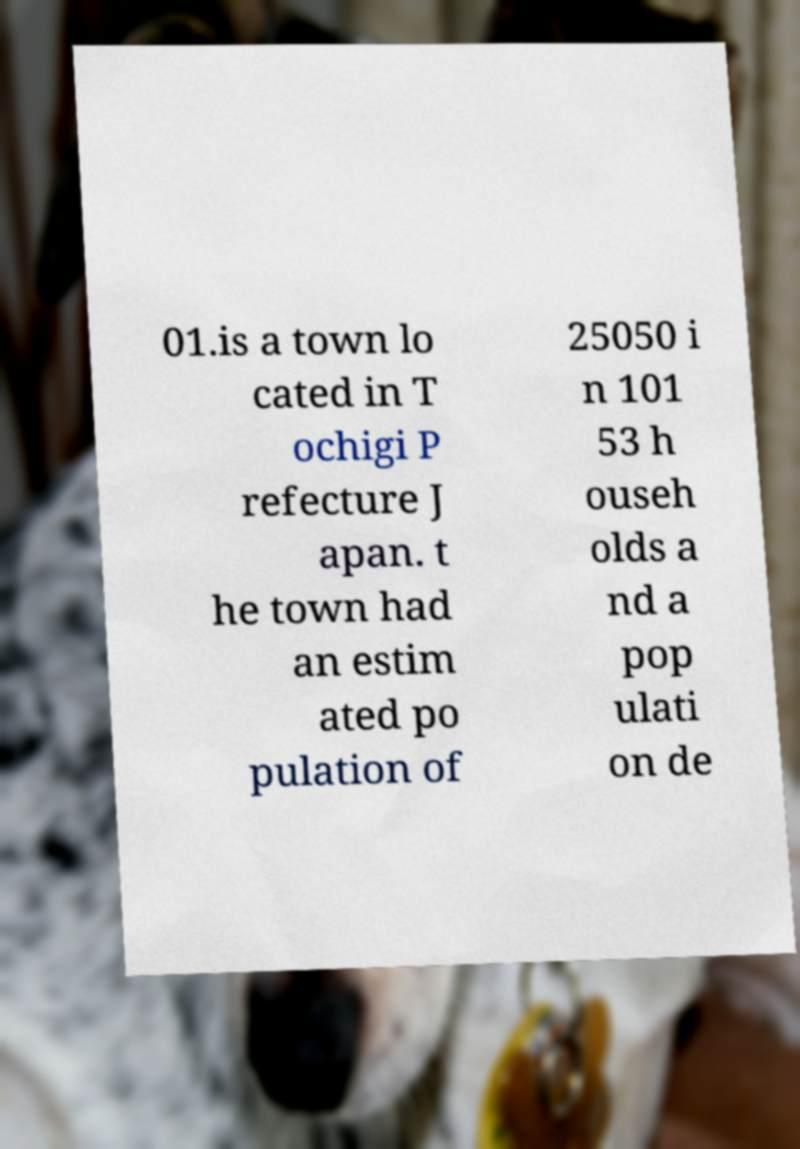Could you extract and type out the text from this image? 01.is a town lo cated in T ochigi P refecture J apan. t he town had an estim ated po pulation of 25050 i n 101 53 h ouseh olds a nd a pop ulati on de 